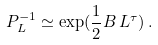Convert formula to latex. <formula><loc_0><loc_0><loc_500><loc_500>P _ { L } ^ { - 1 } \simeq \exp ( \frac { 1 } { 2 } B \, L ^ { \tau } ) \, .</formula> 